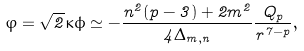Convert formula to latex. <formula><loc_0><loc_0><loc_500><loc_500>\varphi = \sqrt { 2 } \kappa \phi \simeq - \frac { n ^ { 2 } ( p - 3 ) + 2 m ^ { 2 } } { 4 \Delta _ { m , n } } \frac { Q _ { p } } { r ^ { 7 - p } } ,</formula> 